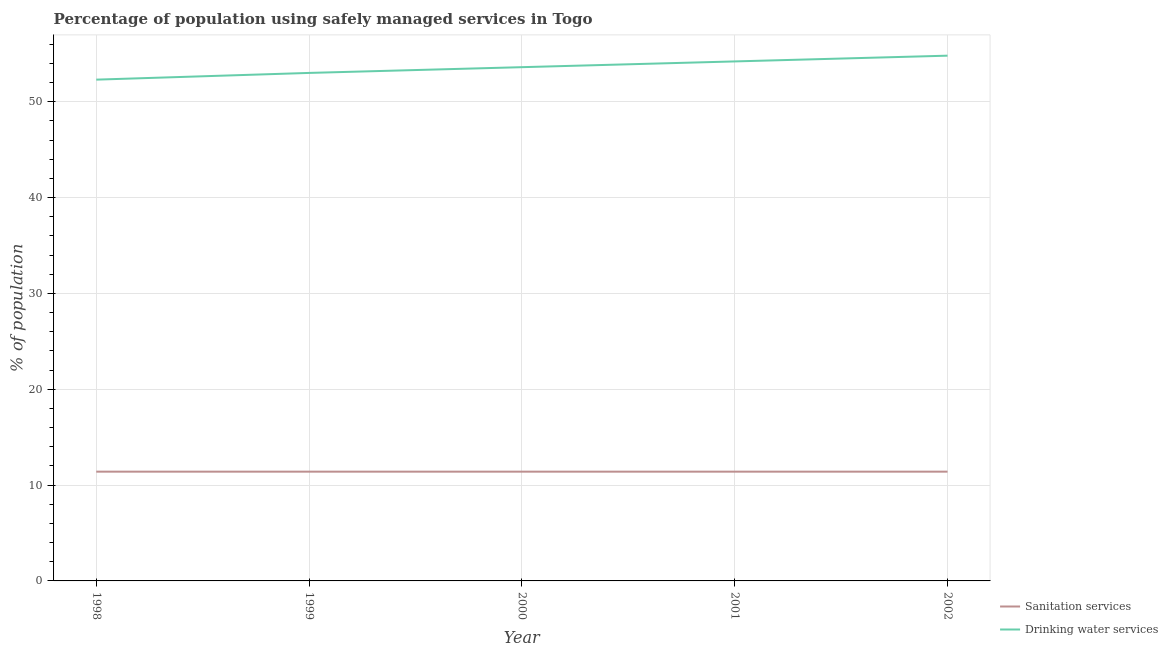Does the line corresponding to percentage of population who used sanitation services intersect with the line corresponding to percentage of population who used drinking water services?
Make the answer very short. No. Across all years, what is the maximum percentage of population who used sanitation services?
Make the answer very short. 11.4. Across all years, what is the minimum percentage of population who used drinking water services?
Make the answer very short. 52.3. In which year was the percentage of population who used sanitation services maximum?
Provide a short and direct response. 1998. In which year was the percentage of population who used drinking water services minimum?
Your answer should be very brief. 1998. What is the total percentage of population who used drinking water services in the graph?
Your answer should be compact. 267.9. What is the difference between the percentage of population who used drinking water services in 2001 and that in 2002?
Provide a short and direct response. -0.6. What is the difference between the percentage of population who used sanitation services in 1999 and the percentage of population who used drinking water services in 1998?
Make the answer very short. -40.9. In the year 2001, what is the difference between the percentage of population who used drinking water services and percentage of population who used sanitation services?
Give a very brief answer. 42.8. In how many years, is the percentage of population who used sanitation services greater than 14 %?
Your answer should be very brief. 0. Is the difference between the percentage of population who used sanitation services in 2001 and 2002 greater than the difference between the percentage of population who used drinking water services in 2001 and 2002?
Make the answer very short. Yes. What is the difference between the highest and the second highest percentage of population who used drinking water services?
Offer a terse response. 0.6. What is the difference between the highest and the lowest percentage of population who used drinking water services?
Provide a short and direct response. 2.5. Are the values on the major ticks of Y-axis written in scientific E-notation?
Make the answer very short. No. How many legend labels are there?
Provide a succinct answer. 2. How are the legend labels stacked?
Ensure brevity in your answer.  Vertical. What is the title of the graph?
Provide a short and direct response. Percentage of population using safely managed services in Togo. What is the label or title of the X-axis?
Ensure brevity in your answer.  Year. What is the label or title of the Y-axis?
Offer a very short reply. % of population. What is the % of population in Sanitation services in 1998?
Provide a succinct answer. 11.4. What is the % of population in Drinking water services in 1998?
Your response must be concise. 52.3. What is the % of population of Sanitation services in 1999?
Offer a terse response. 11.4. What is the % of population in Drinking water services in 1999?
Provide a succinct answer. 53. What is the % of population of Sanitation services in 2000?
Your answer should be compact. 11.4. What is the % of population in Drinking water services in 2000?
Your response must be concise. 53.6. What is the % of population of Drinking water services in 2001?
Offer a terse response. 54.2. What is the % of population of Drinking water services in 2002?
Ensure brevity in your answer.  54.8. Across all years, what is the maximum % of population in Drinking water services?
Ensure brevity in your answer.  54.8. Across all years, what is the minimum % of population in Sanitation services?
Offer a very short reply. 11.4. Across all years, what is the minimum % of population of Drinking water services?
Give a very brief answer. 52.3. What is the total % of population in Drinking water services in the graph?
Offer a terse response. 267.9. What is the difference between the % of population of Sanitation services in 1998 and that in 1999?
Your answer should be very brief. 0. What is the difference between the % of population in Sanitation services in 1998 and that in 2001?
Offer a terse response. 0. What is the difference between the % of population of Drinking water services in 1998 and that in 2002?
Your answer should be very brief. -2.5. What is the difference between the % of population in Sanitation services in 1999 and that in 2000?
Offer a terse response. 0. What is the difference between the % of population in Sanitation services in 1999 and that in 2001?
Give a very brief answer. 0. What is the difference between the % of population of Drinking water services in 1999 and that in 2001?
Your response must be concise. -1.2. What is the difference between the % of population of Sanitation services in 1999 and that in 2002?
Give a very brief answer. 0. What is the difference between the % of population in Drinking water services in 1999 and that in 2002?
Give a very brief answer. -1.8. What is the difference between the % of population in Drinking water services in 2000 and that in 2001?
Provide a short and direct response. -0.6. What is the difference between the % of population in Sanitation services in 2000 and that in 2002?
Provide a short and direct response. 0. What is the difference between the % of population in Drinking water services in 2001 and that in 2002?
Offer a very short reply. -0.6. What is the difference between the % of population in Sanitation services in 1998 and the % of population in Drinking water services in 1999?
Give a very brief answer. -41.6. What is the difference between the % of population of Sanitation services in 1998 and the % of population of Drinking water services in 2000?
Make the answer very short. -42.2. What is the difference between the % of population in Sanitation services in 1998 and the % of population in Drinking water services in 2001?
Your answer should be very brief. -42.8. What is the difference between the % of population in Sanitation services in 1998 and the % of population in Drinking water services in 2002?
Keep it short and to the point. -43.4. What is the difference between the % of population in Sanitation services in 1999 and the % of population in Drinking water services in 2000?
Provide a succinct answer. -42.2. What is the difference between the % of population in Sanitation services in 1999 and the % of population in Drinking water services in 2001?
Offer a terse response. -42.8. What is the difference between the % of population in Sanitation services in 1999 and the % of population in Drinking water services in 2002?
Your response must be concise. -43.4. What is the difference between the % of population of Sanitation services in 2000 and the % of population of Drinking water services in 2001?
Your answer should be very brief. -42.8. What is the difference between the % of population of Sanitation services in 2000 and the % of population of Drinking water services in 2002?
Ensure brevity in your answer.  -43.4. What is the difference between the % of population in Sanitation services in 2001 and the % of population in Drinking water services in 2002?
Make the answer very short. -43.4. What is the average % of population of Drinking water services per year?
Your response must be concise. 53.58. In the year 1998, what is the difference between the % of population in Sanitation services and % of population in Drinking water services?
Keep it short and to the point. -40.9. In the year 1999, what is the difference between the % of population in Sanitation services and % of population in Drinking water services?
Provide a succinct answer. -41.6. In the year 2000, what is the difference between the % of population of Sanitation services and % of population of Drinking water services?
Provide a short and direct response. -42.2. In the year 2001, what is the difference between the % of population in Sanitation services and % of population in Drinking water services?
Keep it short and to the point. -42.8. In the year 2002, what is the difference between the % of population of Sanitation services and % of population of Drinking water services?
Your response must be concise. -43.4. What is the ratio of the % of population of Drinking water services in 1998 to that in 2000?
Offer a terse response. 0.98. What is the ratio of the % of population of Sanitation services in 1998 to that in 2001?
Your response must be concise. 1. What is the ratio of the % of population of Drinking water services in 1998 to that in 2001?
Your answer should be compact. 0.96. What is the ratio of the % of population of Drinking water services in 1998 to that in 2002?
Offer a very short reply. 0.95. What is the ratio of the % of population of Sanitation services in 1999 to that in 2000?
Your answer should be compact. 1. What is the ratio of the % of population of Drinking water services in 1999 to that in 2001?
Your answer should be compact. 0.98. What is the ratio of the % of population in Sanitation services in 1999 to that in 2002?
Provide a succinct answer. 1. What is the ratio of the % of population in Drinking water services in 1999 to that in 2002?
Your answer should be very brief. 0.97. What is the ratio of the % of population in Drinking water services in 2000 to that in 2001?
Ensure brevity in your answer.  0.99. What is the ratio of the % of population of Drinking water services in 2000 to that in 2002?
Give a very brief answer. 0.98. What is the ratio of the % of population of Drinking water services in 2001 to that in 2002?
Make the answer very short. 0.99. What is the difference between the highest and the second highest % of population of Sanitation services?
Your answer should be very brief. 0. What is the difference between the highest and the second highest % of population in Drinking water services?
Provide a short and direct response. 0.6. What is the difference between the highest and the lowest % of population of Sanitation services?
Provide a short and direct response. 0. What is the difference between the highest and the lowest % of population of Drinking water services?
Provide a succinct answer. 2.5. 